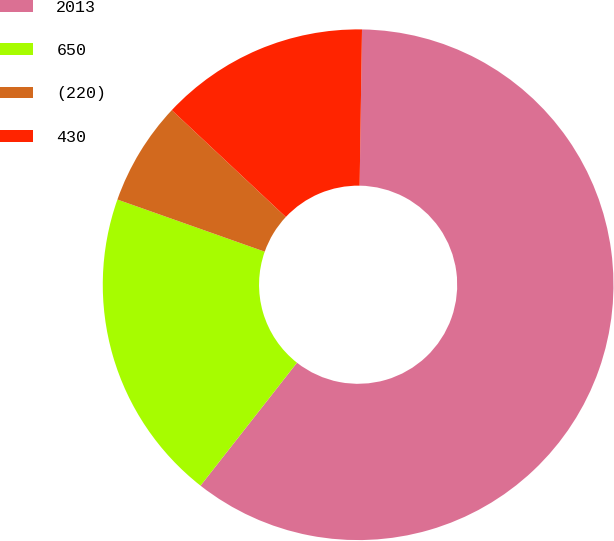Convert chart. <chart><loc_0><loc_0><loc_500><loc_500><pie_chart><fcel>2013<fcel>650<fcel>(220)<fcel>430<nl><fcel>60.35%<fcel>19.83%<fcel>6.57%<fcel>13.26%<nl></chart> 